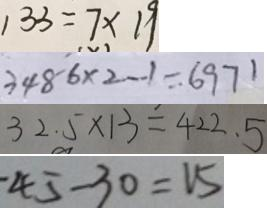<formula> <loc_0><loc_0><loc_500><loc_500>1 3 3 = 7 \times 1 9 
 3 4 8 - 6 \times 2 - 1 = 6 9 7 1 
 3 2 . 5 \times 1 3 = 4 2 2 . 5 
 4 5 - 3 0 = 1 5</formula> 